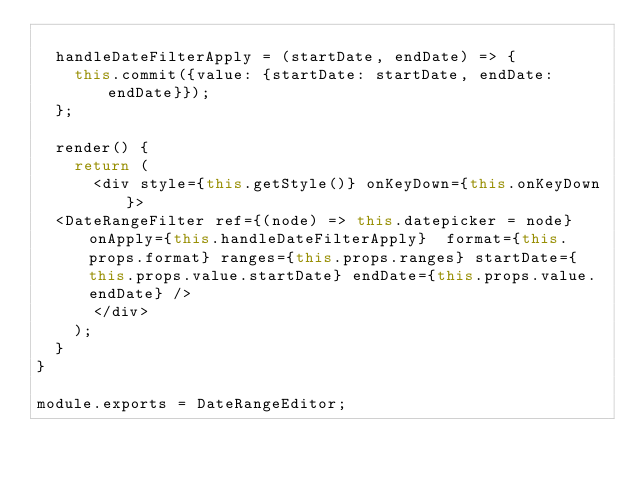<code> <loc_0><loc_0><loc_500><loc_500><_JavaScript_>
  handleDateFilterApply = (startDate, endDate) => {
    this.commit({value: {startDate: startDate, endDate: endDate}});
  };

  render() {
    return (
      <div style={this.getStyle()} onKeyDown={this.onKeyDown}>
  <DateRangeFilter ref={(node) => this.datepicker = node} onApply={this.handleDateFilterApply}  format={this.props.format} ranges={this.props.ranges} startDate={this.props.value.startDate} endDate={this.props.value.endDate} />
      </div>
    );
  }
}

module.exports = DateRangeEditor;
</code> 